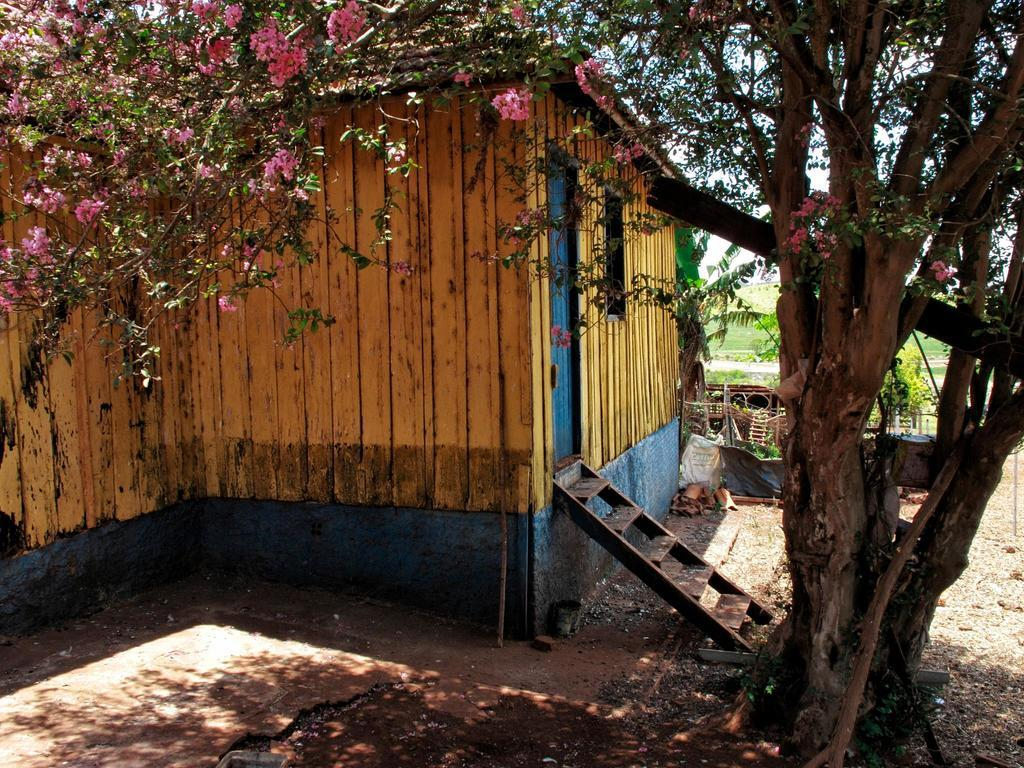What structure is located on the left side of the image? There is a building on the left side of the image. What features can be seen on the building? The building has a door, a window, and steps. What type of vegetation is near the building? There is a tree near the building. What can be seen in the background of the image? There are plants in the background of the image. How many items can be seen in the image? There are many items in the image. Can you tell me how many teeth the church has in the image? There is no church present in the image, and therefore no teeth can be associated with it. 